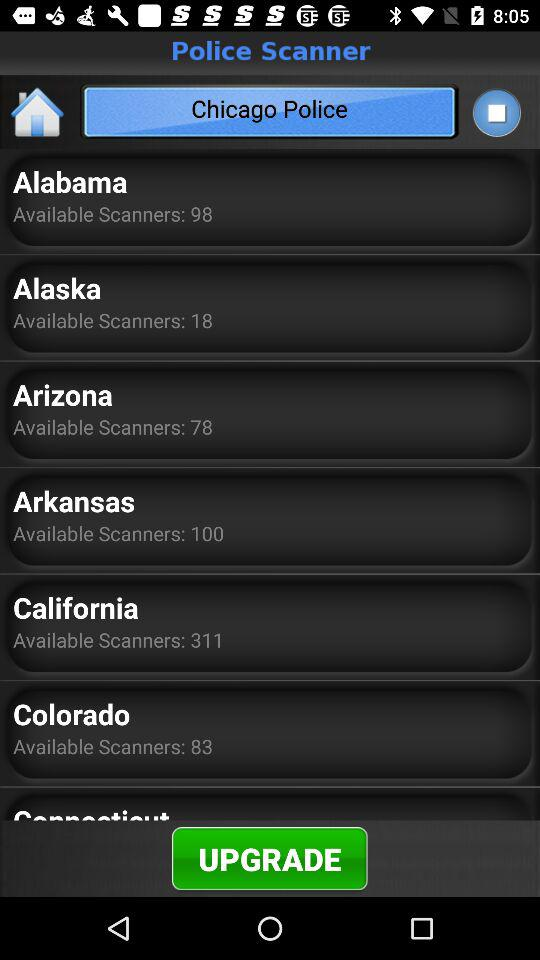Which city police are given? The police are from Chicago. 